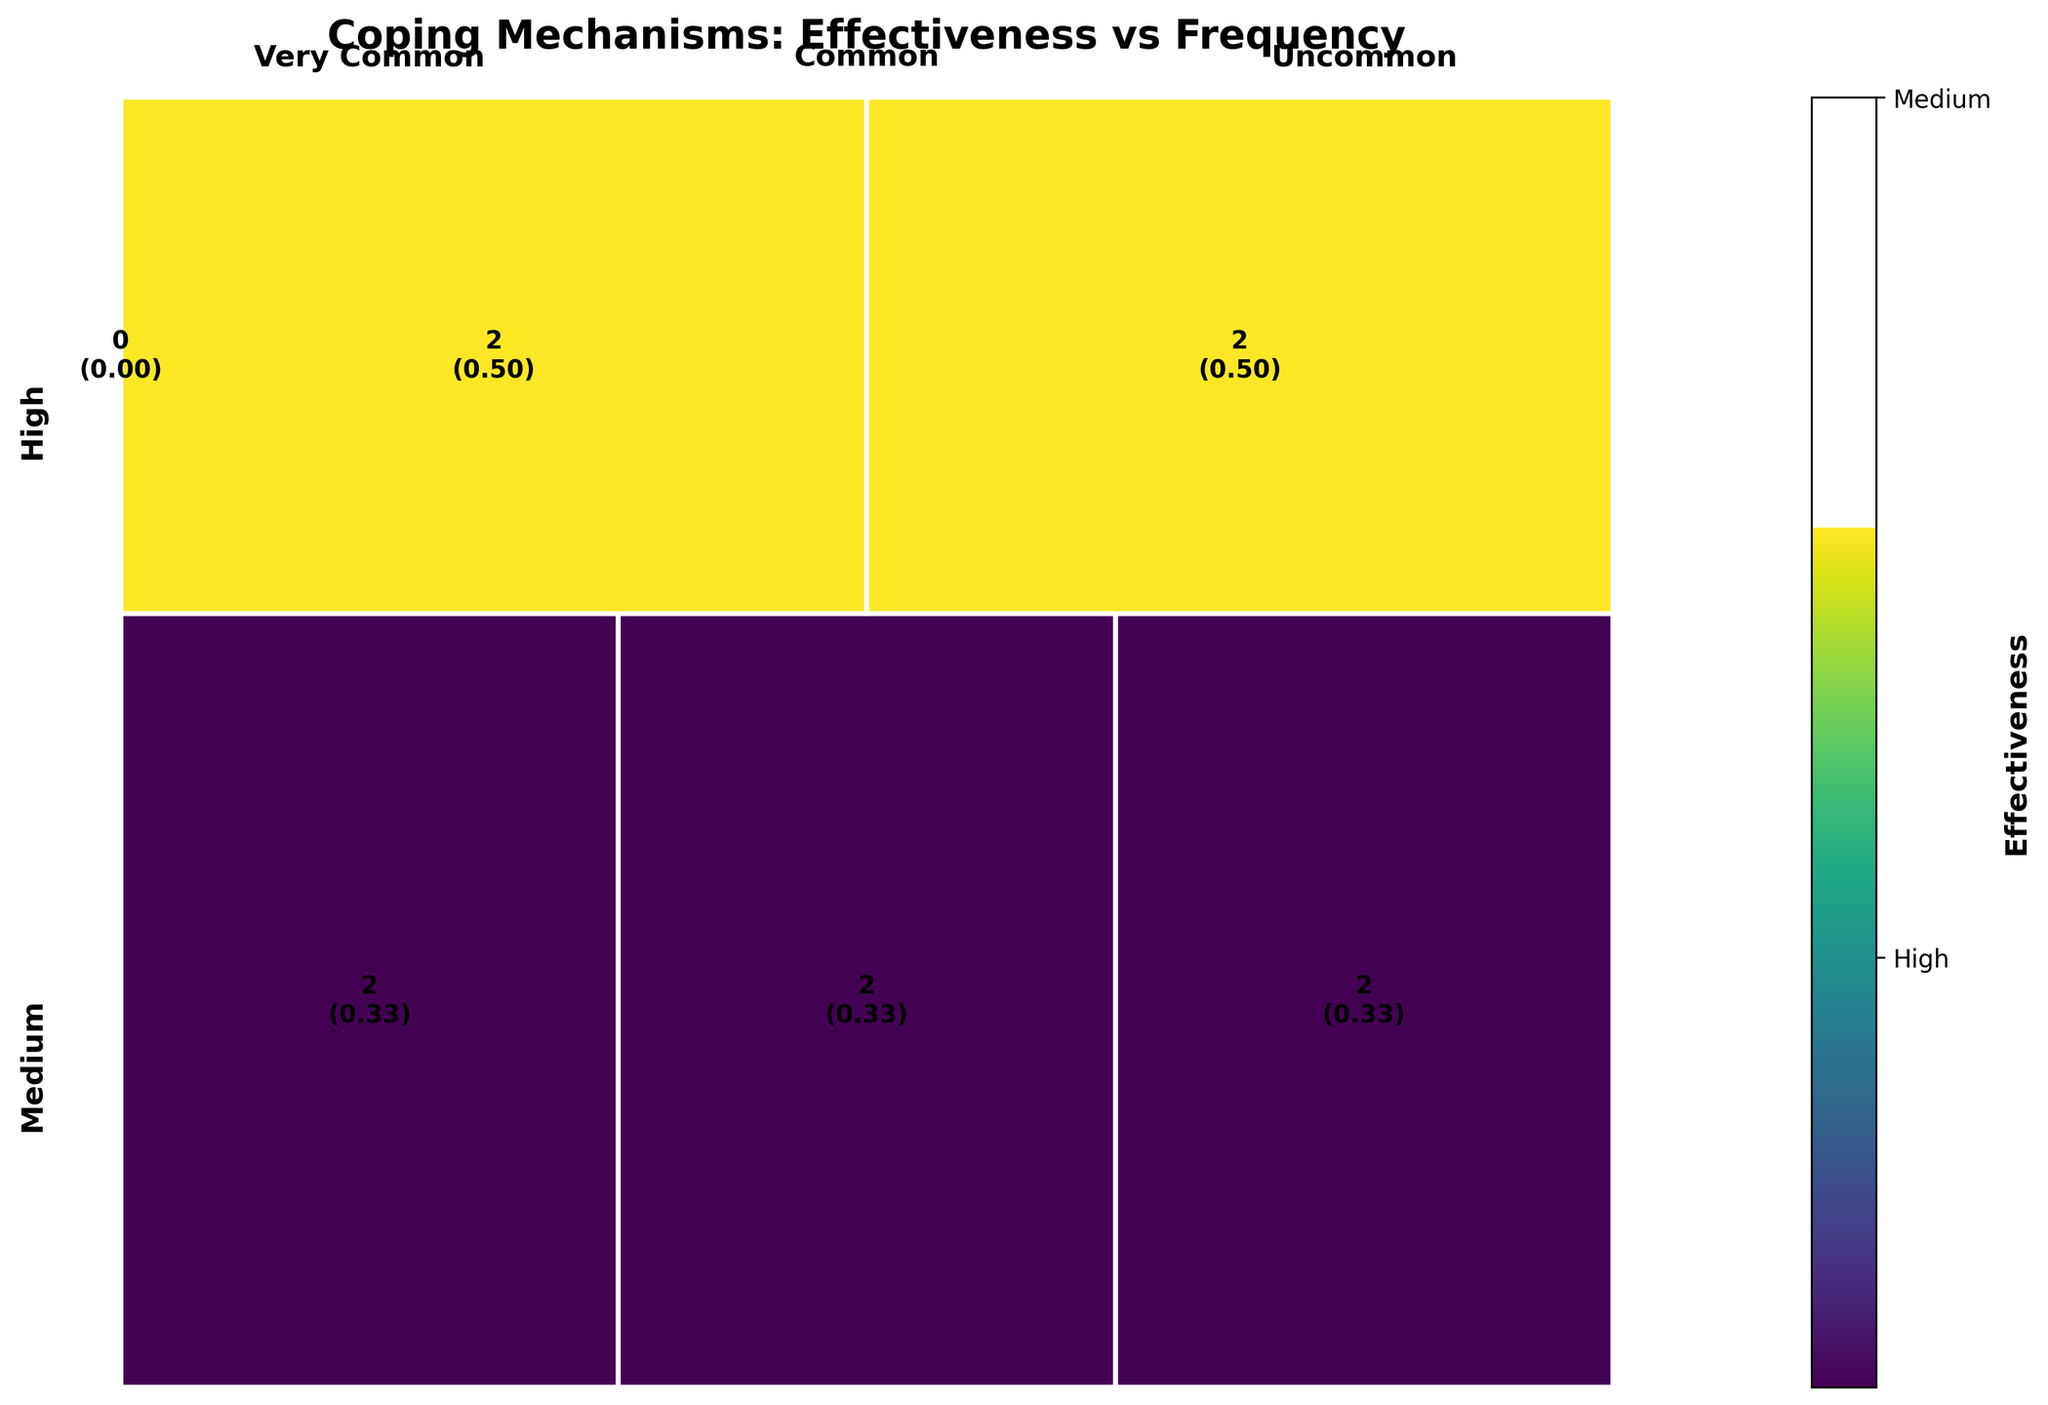How many coping mechanisms have high effectiveness? The plot distinguishes between coping mechanisms based on their effectiveness. You can count the number of distinct high-effectiveness categories in the plot.
Answer: 6 Which coping mechanism frequency category has the most high-effectiveness techniques? By examining the frequencies within the high-effectiveness segment, you can compare the sizes of each frequency category.
Answer: Very Common How many high-effectiveness coping mechanisms are used very commonly? Look at the high-effectiveness segment and identify the number of mechanisms that fall into the very common frequency category.
Answer: 2 (Deep Breathing, Pre-Performance Routines) What is the least frequently used medium-effectiveness coping mechanism? In the medium-effectiveness section, find the smallest segment that signifies the uncommon frequency category.
Answer: Mindfulness Meditation or Imagery Rehearsal (both are uncommon) Which frequency has the highest total number of coping mechanisms? Summing up all categories for each frequency, identify which frequency has the most coping mechanisms.
Answer: Common Compare the usage frequency of high-effectiveness and medium-effectiveness coping mechanisms. Which has a higher median effectiveness rating? By comparing the segment sizes within the high and medium effectiveness categories, determine which type has the larger segments, indicating their usage frequency.
Answer: High effectiveness has larger segments for very common and common usage frequencies Which coping mechanisms appear in at least two different effectiveness categories? Identify any coping mechanisms represented in both high and medium effectiveness categories from the plot’s segmented rectangles. This may require cross-referencing copings listed in different segments.
Answer: None Are there any coping mechanisms used infrequently regardless of their effectiveness? Examine segments labeled uncommon and check both high and medium effectiveness sections for colors representing few coping mechanisms.
Answer: Yes, Progressive Muscle Relaxation, Imagery Rehearsal, and Cognitive Restructuring are uncommon What percentage of high-effectiveness coping mechanisms are commonly used? Count the number of high-effectiveness coping mechanisms labeled as common, divide by the total number of high-effectiveness coping mechanisms, and multiply by 100.
Answer: 50% Which coping mechanism has a higher usage frequency: Cognitive Restructuring or Visualization? Compare the frequency categories of these two coping mechanisms to determine which has a higher base in the plot.
Answer: Visualization (Common) 